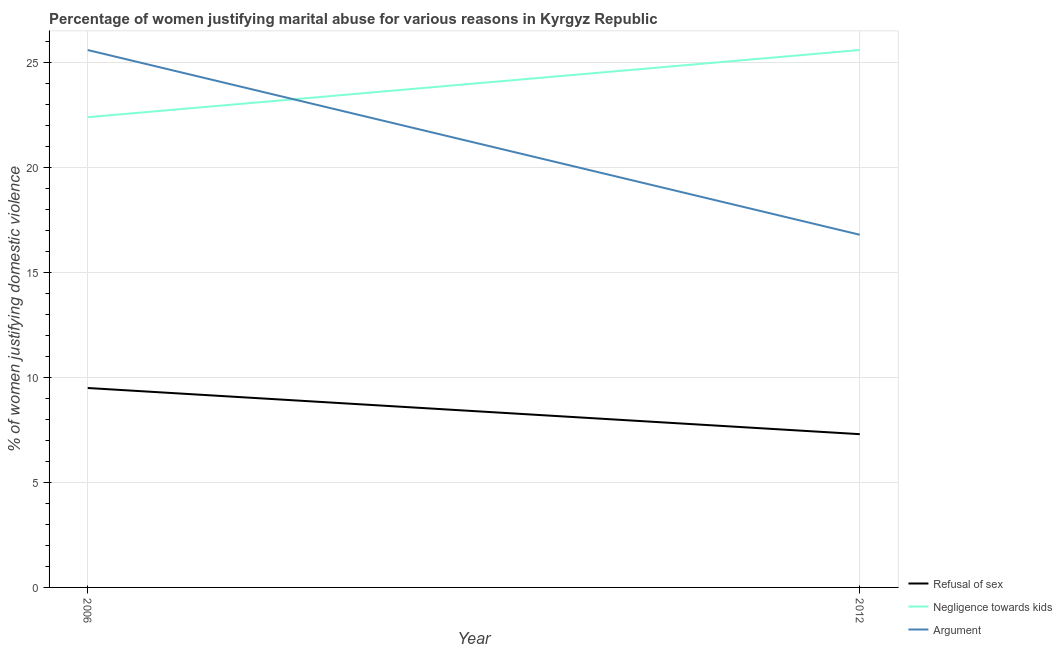How many different coloured lines are there?
Your answer should be compact. 3. Does the line corresponding to percentage of women justifying domestic violence due to arguments intersect with the line corresponding to percentage of women justifying domestic violence due to negligence towards kids?
Offer a terse response. Yes. Is the number of lines equal to the number of legend labels?
Provide a succinct answer. Yes. Across all years, what is the maximum percentage of women justifying domestic violence due to negligence towards kids?
Offer a very short reply. 25.6. Across all years, what is the minimum percentage of women justifying domestic violence due to negligence towards kids?
Provide a succinct answer. 22.4. In which year was the percentage of women justifying domestic violence due to refusal of sex maximum?
Keep it short and to the point. 2006. What is the total percentage of women justifying domestic violence due to arguments in the graph?
Offer a very short reply. 42.4. What is the difference between the percentage of women justifying domestic violence due to arguments in 2006 and that in 2012?
Keep it short and to the point. 8.8. What is the difference between the percentage of women justifying domestic violence due to negligence towards kids in 2012 and the percentage of women justifying domestic violence due to refusal of sex in 2006?
Make the answer very short. 16.1. What is the average percentage of women justifying domestic violence due to arguments per year?
Ensure brevity in your answer.  21.2. In the year 2012, what is the difference between the percentage of women justifying domestic violence due to negligence towards kids and percentage of women justifying domestic violence due to refusal of sex?
Your response must be concise. 18.3. In how many years, is the percentage of women justifying domestic violence due to refusal of sex greater than 4 %?
Keep it short and to the point. 2. What is the ratio of the percentage of women justifying domestic violence due to arguments in 2006 to that in 2012?
Offer a terse response. 1.52. In how many years, is the percentage of women justifying domestic violence due to refusal of sex greater than the average percentage of women justifying domestic violence due to refusal of sex taken over all years?
Give a very brief answer. 1. How many years are there in the graph?
Ensure brevity in your answer.  2. What is the difference between two consecutive major ticks on the Y-axis?
Make the answer very short. 5. Does the graph contain grids?
Provide a succinct answer. Yes. Where does the legend appear in the graph?
Your answer should be compact. Bottom right. How many legend labels are there?
Your response must be concise. 3. What is the title of the graph?
Offer a terse response. Percentage of women justifying marital abuse for various reasons in Kyrgyz Republic. What is the label or title of the X-axis?
Give a very brief answer. Year. What is the label or title of the Y-axis?
Your response must be concise. % of women justifying domestic violence. What is the % of women justifying domestic violence of Negligence towards kids in 2006?
Keep it short and to the point. 22.4. What is the % of women justifying domestic violence in Argument in 2006?
Your response must be concise. 25.6. What is the % of women justifying domestic violence of Refusal of sex in 2012?
Your response must be concise. 7.3. What is the % of women justifying domestic violence of Negligence towards kids in 2012?
Ensure brevity in your answer.  25.6. What is the % of women justifying domestic violence in Argument in 2012?
Your answer should be very brief. 16.8. Across all years, what is the maximum % of women justifying domestic violence of Refusal of sex?
Your answer should be compact. 9.5. Across all years, what is the maximum % of women justifying domestic violence in Negligence towards kids?
Offer a terse response. 25.6. Across all years, what is the maximum % of women justifying domestic violence of Argument?
Provide a short and direct response. 25.6. Across all years, what is the minimum % of women justifying domestic violence of Refusal of sex?
Provide a short and direct response. 7.3. Across all years, what is the minimum % of women justifying domestic violence of Negligence towards kids?
Your answer should be very brief. 22.4. What is the total % of women justifying domestic violence of Refusal of sex in the graph?
Provide a succinct answer. 16.8. What is the total % of women justifying domestic violence of Argument in the graph?
Provide a succinct answer. 42.4. What is the difference between the % of women justifying domestic violence in Argument in 2006 and that in 2012?
Ensure brevity in your answer.  8.8. What is the difference between the % of women justifying domestic violence in Refusal of sex in 2006 and the % of women justifying domestic violence in Negligence towards kids in 2012?
Offer a terse response. -16.1. What is the difference between the % of women justifying domestic violence in Refusal of sex in 2006 and the % of women justifying domestic violence in Argument in 2012?
Offer a very short reply. -7.3. What is the average % of women justifying domestic violence in Refusal of sex per year?
Offer a terse response. 8.4. What is the average % of women justifying domestic violence in Negligence towards kids per year?
Your answer should be very brief. 24. What is the average % of women justifying domestic violence of Argument per year?
Your response must be concise. 21.2. In the year 2006, what is the difference between the % of women justifying domestic violence in Refusal of sex and % of women justifying domestic violence in Negligence towards kids?
Your answer should be compact. -12.9. In the year 2006, what is the difference between the % of women justifying domestic violence in Refusal of sex and % of women justifying domestic violence in Argument?
Your answer should be compact. -16.1. In the year 2006, what is the difference between the % of women justifying domestic violence of Negligence towards kids and % of women justifying domestic violence of Argument?
Offer a terse response. -3.2. In the year 2012, what is the difference between the % of women justifying domestic violence of Refusal of sex and % of women justifying domestic violence of Negligence towards kids?
Your response must be concise. -18.3. In the year 2012, what is the difference between the % of women justifying domestic violence of Refusal of sex and % of women justifying domestic violence of Argument?
Provide a short and direct response. -9.5. In the year 2012, what is the difference between the % of women justifying domestic violence of Negligence towards kids and % of women justifying domestic violence of Argument?
Provide a succinct answer. 8.8. What is the ratio of the % of women justifying domestic violence of Refusal of sex in 2006 to that in 2012?
Ensure brevity in your answer.  1.3. What is the ratio of the % of women justifying domestic violence of Argument in 2006 to that in 2012?
Make the answer very short. 1.52. What is the difference between the highest and the second highest % of women justifying domestic violence in Negligence towards kids?
Give a very brief answer. 3.2. What is the difference between the highest and the second highest % of women justifying domestic violence of Argument?
Your answer should be very brief. 8.8. What is the difference between the highest and the lowest % of women justifying domestic violence of Refusal of sex?
Your answer should be very brief. 2.2. What is the difference between the highest and the lowest % of women justifying domestic violence of Argument?
Give a very brief answer. 8.8. 